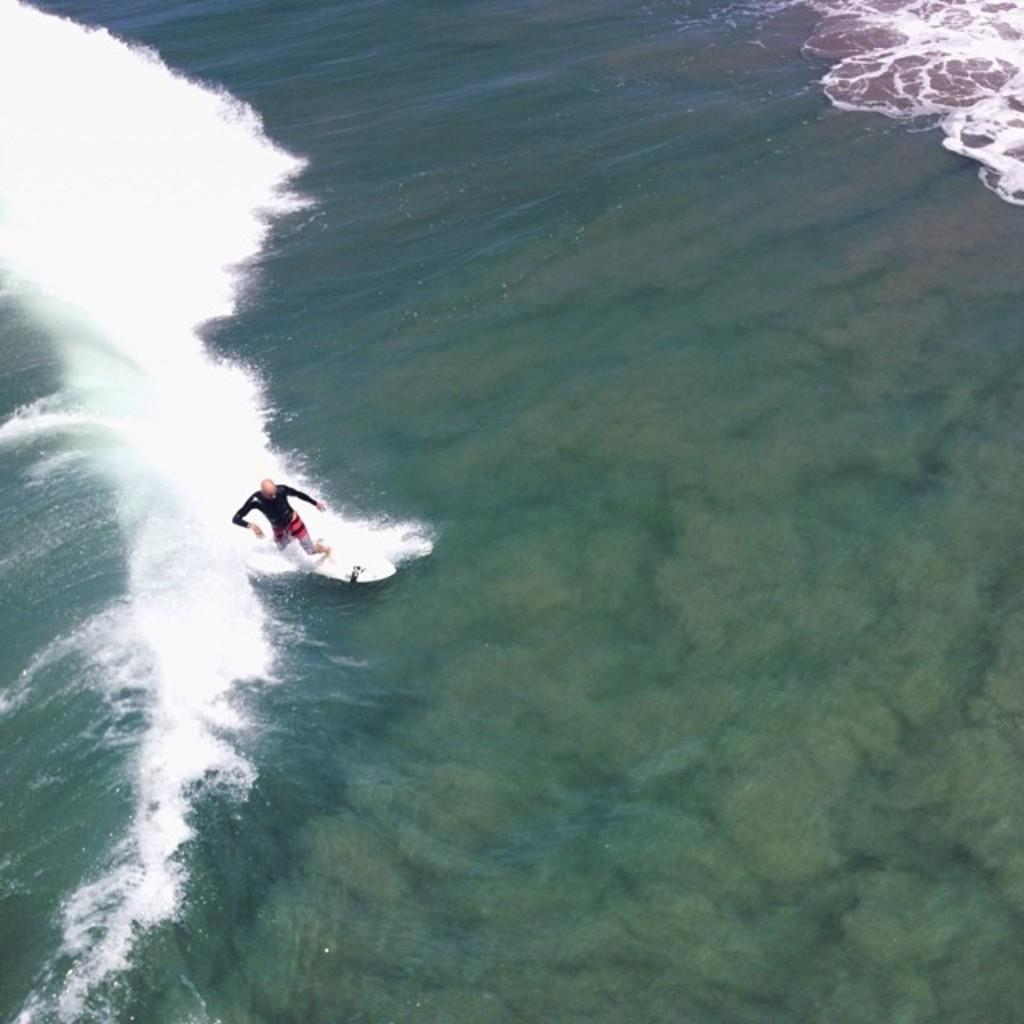What type of natural body of water is present in the image? There is a sea in the image. Can you describe the person in the image? There is a man in the image. What is the man doing in the image? The man is standing on a surfboard and surfing in the sea. What type of wound can be seen on the man's hand in the image? There is no wound visible on the man's hand in the image. What type of light bulb is used to illuminate the sea in the image? There is no light bulb present in the image, as it is a natural body of water. 